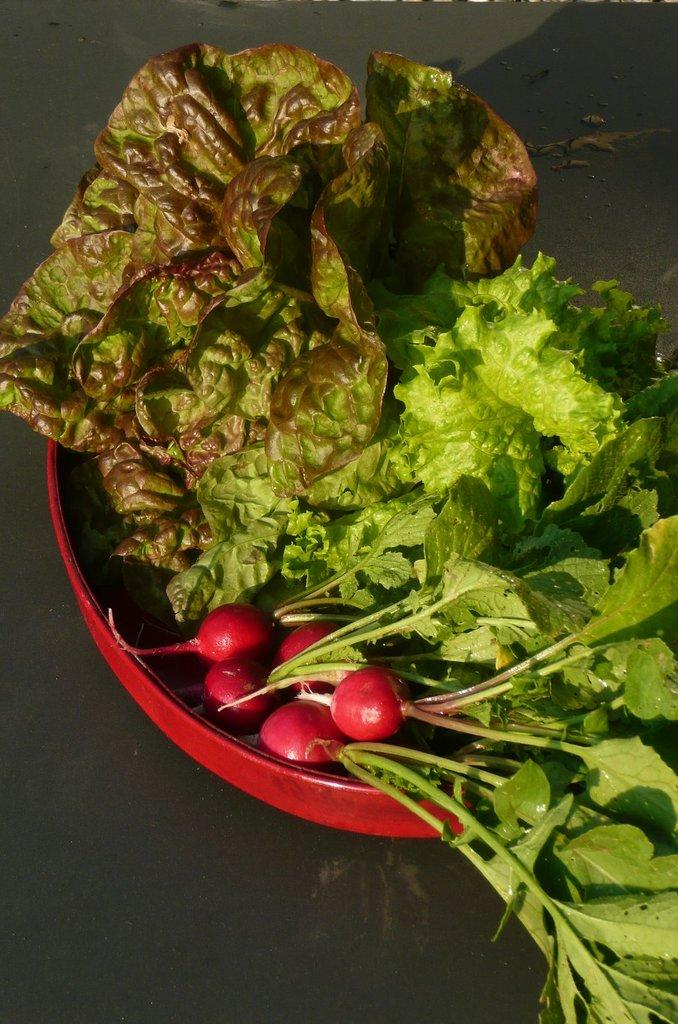What is in the bowl that is visible in the image? There is a bowl in the image, and it contains turnips and leafy vegetables. Can you describe the contents of the bowl in more detail? The bowl contains turnips and leafy vegetables, which are both types of vegetables. How does the bowl control the payment for the vegetables in the image? The bowl does not control any payment for the vegetables; it is simply a container for the vegetables. 